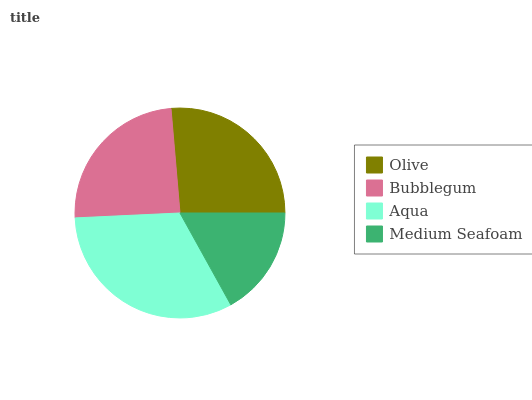Is Medium Seafoam the minimum?
Answer yes or no. Yes. Is Aqua the maximum?
Answer yes or no. Yes. Is Bubblegum the minimum?
Answer yes or no. No. Is Bubblegum the maximum?
Answer yes or no. No. Is Olive greater than Bubblegum?
Answer yes or no. Yes. Is Bubblegum less than Olive?
Answer yes or no. Yes. Is Bubblegum greater than Olive?
Answer yes or no. No. Is Olive less than Bubblegum?
Answer yes or no. No. Is Olive the high median?
Answer yes or no. Yes. Is Bubblegum the low median?
Answer yes or no. Yes. Is Aqua the high median?
Answer yes or no. No. Is Olive the low median?
Answer yes or no. No. 